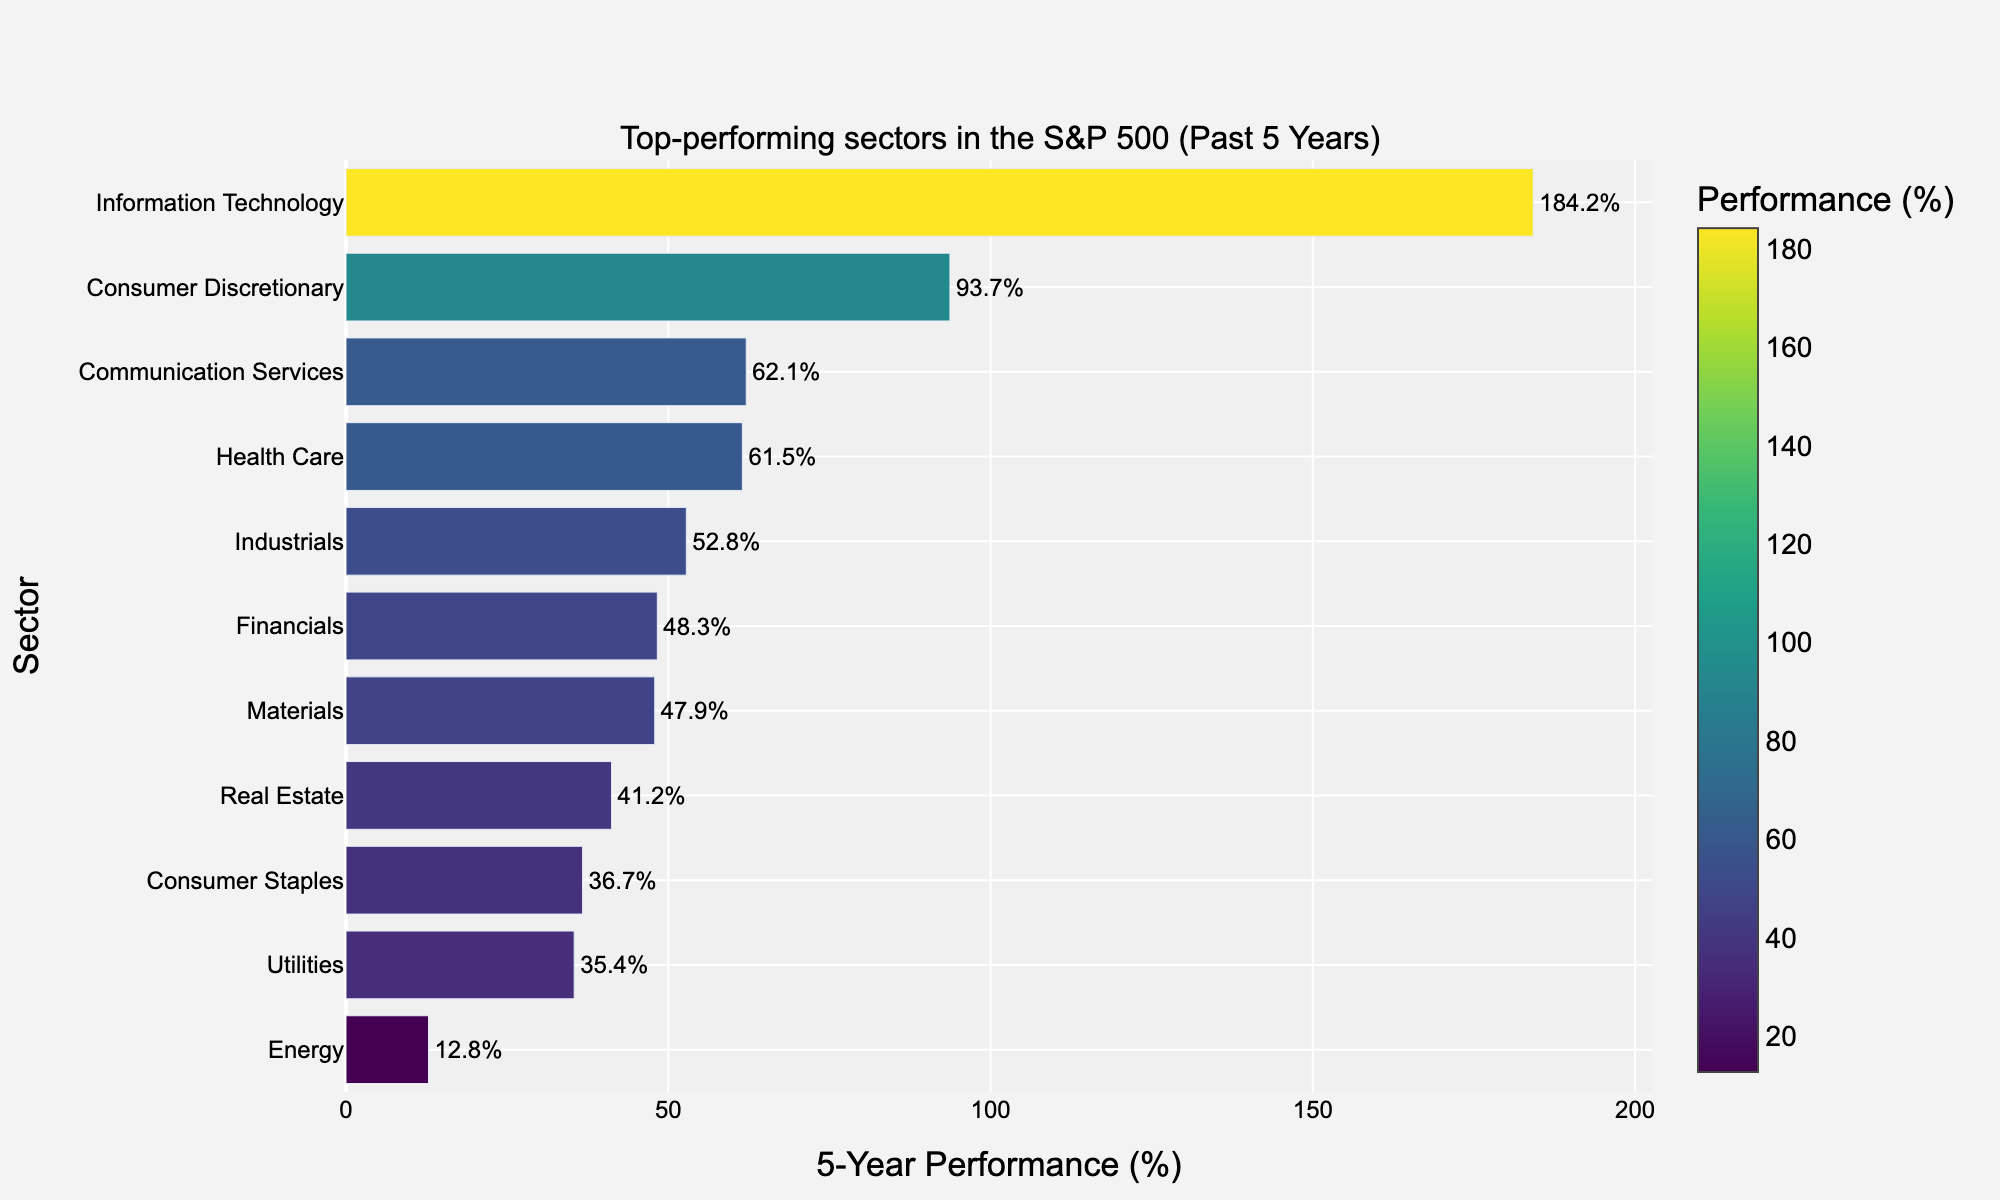Which sector has the highest 5-year performance? The bar chart indicates that the Information Technology sector has the longest bar among all the sectors.
Answer: Information Technology Which sector has the lowest 5-year performance? By observing the bar chart, the Energy sector has the shortest bar in terms of 5-year performance.
Answer: Energy What is the performance difference between Information Technology and Consumer Discretionary? Information Technology has a 5-year performance of 184.2%, while Consumer Discretionary has 93.7%. The difference is calculated as 184.2% - 93.7% = 90.5%.
Answer: 90.5% How many sectors have a 5-year performance above 50%? The sectors with performance above 50% are Information Technology, Consumer Discretionary, Communication Services, Health Care, and Industrials, totaling 5 sectors.
Answer: 5 Which sector shows a similar performance to Health Care? Health Care has a 5-year performance of 61.5%. The Industrial sector is closest with a performance of 52.8%, followed by Communication Services with 62.1%.
Answer: Communication Services What is the average 5-year performance of the bottom three sectors? The bottom three sectors are Real Estate (41.2%), Consumer Staples (36.7%), and Utilities (35.4%). The average is calculated as (41.2% + 36.7% + 35.4%) / 3 = 37.76%.
Answer: 37.76% Which sector's performance is just below Information Technology? Observing the bar chart, Consumer Discretionary has the second longest bar, just below Information Technology.
Answer: Consumer Discretionary Does Energy perform better than Utilities? By comparing the lengths of the bars, Utilities have a performance of 35.4%, whereas Energy has 12.8%, indicating Utilities performed better than Energy.
Answer: No What is the color gradient representation for Financials in the bar chart? The bar chart uses the Viridis colorscale with color representing performance percentage. Financials, with a 5-year performance of 48.3%, would fall into the middle range of the colorscale, showing a medium-level shade.
Answer: Medium shade 